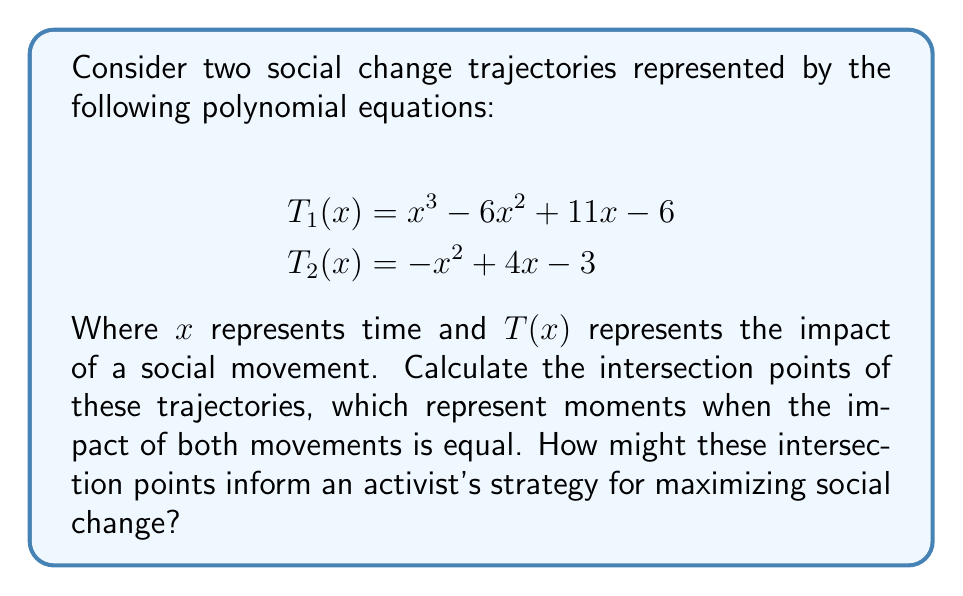Can you solve this math problem? To find the intersection points, we need to solve the equation:

$$T_1(x) = T_2(x)$$

1) Substitute the given equations:
   $$x^3 - 6x^2 + 11x - 6 = -x^2 + 4x - 3$$

2) Rearrange the equation to standard form:
   $$x^3 - 5x^2 + 7x - 3 = 0$$

3) This is a cubic equation. We can solve it using the rational root theorem. The possible rational roots are the factors of the constant term: ±1, ±3.

4) Testing these values, we find that x = 1 is a solution.

5) Divide the polynomial by (x - 1):
   $$(x^3 - 5x^2 + 7x - 3) \div (x - 1) = x^2 - 4x + 3$$

6) The remaining quadratic equation is:
   $$x^2 - 4x + 3 = 0$$

7) Solve using the quadratic formula: $x = \frac{-b \pm \sqrt{b^2 - 4ac}}{2a}$
   $$x = \frac{4 \pm \sqrt{16 - 12}}{2} = \frac{4 \pm 2}{2}$$

8) This gives us two more solutions: x = 3 and x = 1

Therefore, the intersection points are at x = 1 (twice) and x = 3.

For an activist, these intersection points represent moments when both social movements have equal impact. The double intersection at x = 1 suggests a critical moment where the trajectories not only meet but also change their relative positions. The intersection at x = 3 represents another significant moment of equal impact. An activist could use this information to time interventions or coordinate efforts between movements for maximum effect.
Answer: Intersection points: x = 1 (double root) and x = 3 